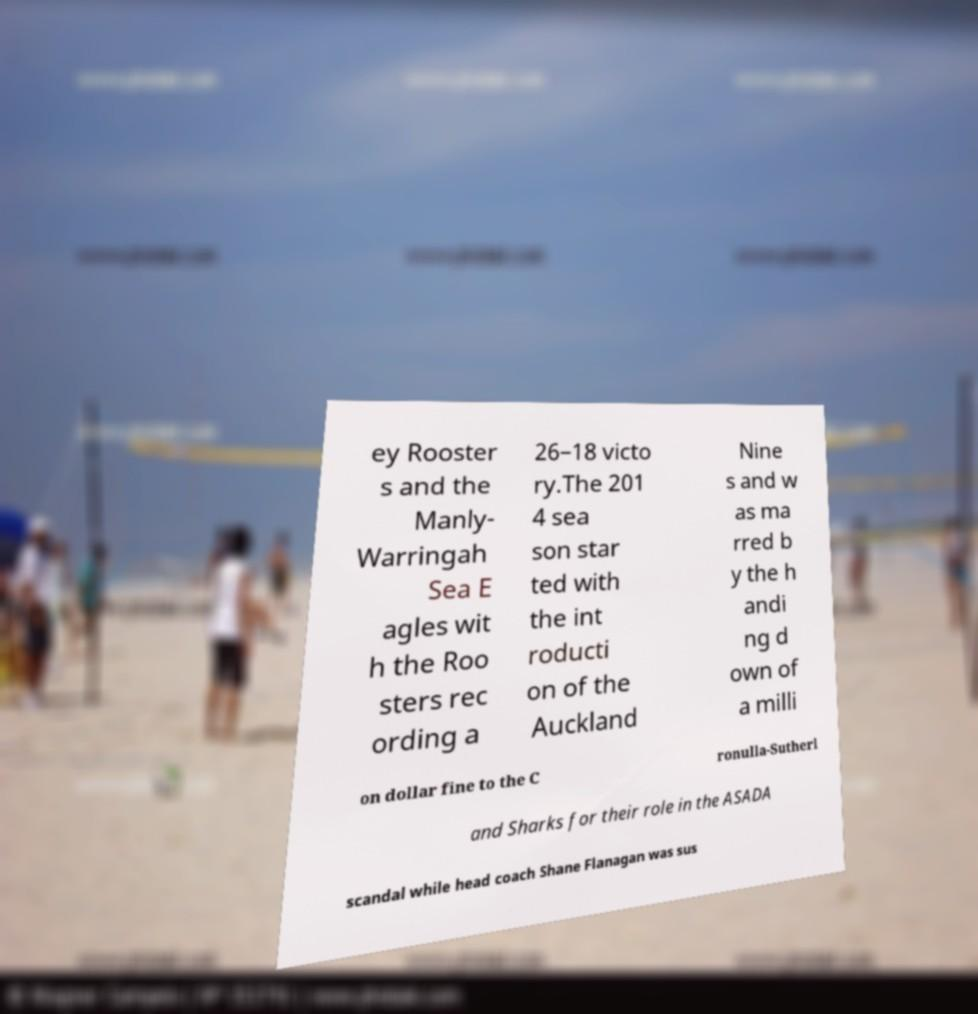For documentation purposes, I need the text within this image transcribed. Could you provide that? ey Rooster s and the Manly- Warringah Sea E agles wit h the Roo sters rec ording a 26–18 victo ry.The 201 4 sea son star ted with the int roducti on of the Auckland Nine s and w as ma rred b y the h andi ng d own of a milli on dollar fine to the C ronulla-Sutherl and Sharks for their role in the ASADA scandal while head coach Shane Flanagan was sus 